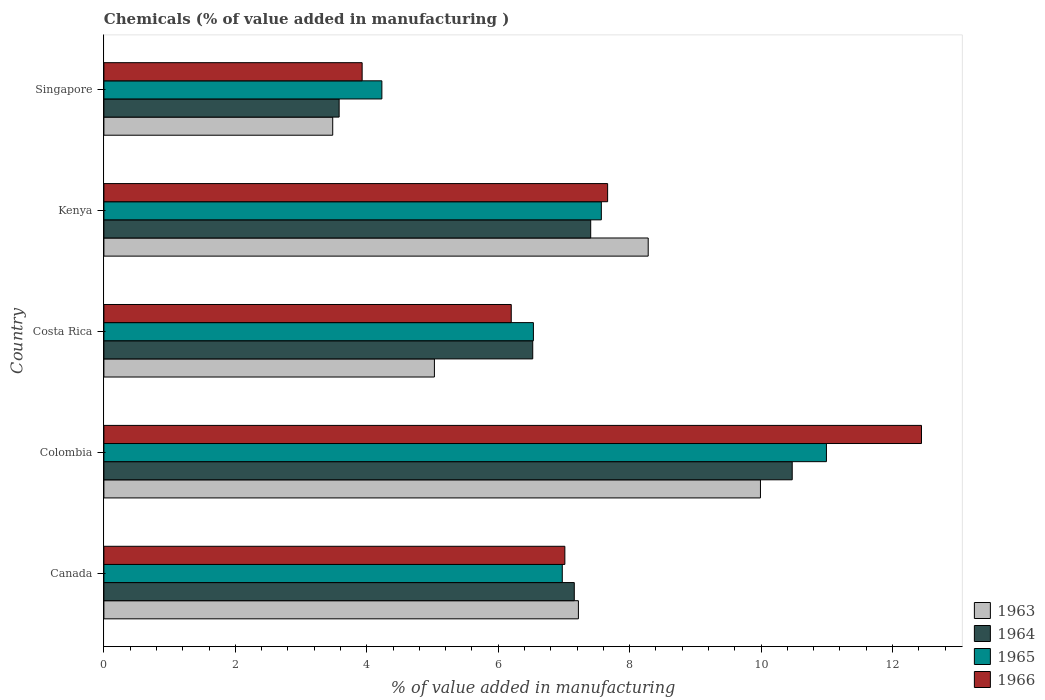How many different coloured bars are there?
Offer a very short reply. 4. Are the number of bars on each tick of the Y-axis equal?
Provide a succinct answer. Yes. How many bars are there on the 5th tick from the top?
Offer a terse response. 4. What is the label of the 2nd group of bars from the top?
Provide a short and direct response. Kenya. In how many cases, is the number of bars for a given country not equal to the number of legend labels?
Offer a terse response. 0. What is the value added in manufacturing chemicals in 1966 in Canada?
Your answer should be very brief. 7.01. Across all countries, what is the maximum value added in manufacturing chemicals in 1965?
Provide a succinct answer. 10.99. Across all countries, what is the minimum value added in manufacturing chemicals in 1965?
Keep it short and to the point. 4.23. In which country was the value added in manufacturing chemicals in 1966 minimum?
Your answer should be very brief. Singapore. What is the total value added in manufacturing chemicals in 1965 in the graph?
Your answer should be compact. 36.31. What is the difference between the value added in manufacturing chemicals in 1964 in Colombia and that in Singapore?
Offer a very short reply. 6.89. What is the difference between the value added in manufacturing chemicals in 1965 in Colombia and the value added in manufacturing chemicals in 1966 in Canada?
Provide a succinct answer. 3.98. What is the average value added in manufacturing chemicals in 1966 per country?
Offer a very short reply. 7.45. What is the difference between the value added in manufacturing chemicals in 1966 and value added in manufacturing chemicals in 1963 in Colombia?
Make the answer very short. 2.45. What is the ratio of the value added in manufacturing chemicals in 1966 in Canada to that in Singapore?
Make the answer very short. 1.78. Is the value added in manufacturing chemicals in 1964 in Canada less than that in Costa Rica?
Give a very brief answer. No. Is the difference between the value added in manufacturing chemicals in 1966 in Colombia and Singapore greater than the difference between the value added in manufacturing chemicals in 1963 in Colombia and Singapore?
Give a very brief answer. Yes. What is the difference between the highest and the second highest value added in manufacturing chemicals in 1965?
Provide a succinct answer. 3.43. What is the difference between the highest and the lowest value added in manufacturing chemicals in 1964?
Make the answer very short. 6.89. Is the sum of the value added in manufacturing chemicals in 1963 in Costa Rica and Singapore greater than the maximum value added in manufacturing chemicals in 1965 across all countries?
Ensure brevity in your answer.  No. What does the 1st bar from the top in Canada represents?
Your response must be concise. 1966. Is it the case that in every country, the sum of the value added in manufacturing chemicals in 1964 and value added in manufacturing chemicals in 1966 is greater than the value added in manufacturing chemicals in 1963?
Make the answer very short. Yes. How many bars are there?
Your answer should be very brief. 20. Are the values on the major ticks of X-axis written in scientific E-notation?
Provide a short and direct response. No. Does the graph contain grids?
Make the answer very short. No. Where does the legend appear in the graph?
Give a very brief answer. Bottom right. What is the title of the graph?
Your response must be concise. Chemicals (% of value added in manufacturing ). What is the label or title of the X-axis?
Keep it short and to the point. % of value added in manufacturing. What is the label or title of the Y-axis?
Offer a very short reply. Country. What is the % of value added in manufacturing in 1963 in Canada?
Provide a short and direct response. 7.22. What is the % of value added in manufacturing in 1964 in Canada?
Your answer should be very brief. 7.16. What is the % of value added in manufacturing of 1965 in Canada?
Give a very brief answer. 6.98. What is the % of value added in manufacturing of 1966 in Canada?
Your answer should be very brief. 7.01. What is the % of value added in manufacturing of 1963 in Colombia?
Your response must be concise. 9.99. What is the % of value added in manufacturing in 1964 in Colombia?
Your response must be concise. 10.47. What is the % of value added in manufacturing of 1965 in Colombia?
Make the answer very short. 10.99. What is the % of value added in manufacturing in 1966 in Colombia?
Offer a very short reply. 12.44. What is the % of value added in manufacturing of 1963 in Costa Rica?
Provide a succinct answer. 5.03. What is the % of value added in manufacturing in 1964 in Costa Rica?
Give a very brief answer. 6.53. What is the % of value added in manufacturing of 1965 in Costa Rica?
Provide a succinct answer. 6.54. What is the % of value added in manufacturing of 1966 in Costa Rica?
Provide a succinct answer. 6.2. What is the % of value added in manufacturing in 1963 in Kenya?
Offer a very short reply. 8.28. What is the % of value added in manufacturing in 1964 in Kenya?
Provide a short and direct response. 7.41. What is the % of value added in manufacturing of 1965 in Kenya?
Your answer should be very brief. 7.57. What is the % of value added in manufacturing in 1966 in Kenya?
Your answer should be very brief. 7.67. What is the % of value added in manufacturing in 1963 in Singapore?
Ensure brevity in your answer.  3.48. What is the % of value added in manufacturing of 1964 in Singapore?
Provide a succinct answer. 3.58. What is the % of value added in manufacturing in 1965 in Singapore?
Your answer should be compact. 4.23. What is the % of value added in manufacturing of 1966 in Singapore?
Your answer should be compact. 3.93. Across all countries, what is the maximum % of value added in manufacturing in 1963?
Your answer should be very brief. 9.99. Across all countries, what is the maximum % of value added in manufacturing of 1964?
Give a very brief answer. 10.47. Across all countries, what is the maximum % of value added in manufacturing in 1965?
Your answer should be compact. 10.99. Across all countries, what is the maximum % of value added in manufacturing in 1966?
Your answer should be very brief. 12.44. Across all countries, what is the minimum % of value added in manufacturing of 1963?
Offer a terse response. 3.48. Across all countries, what is the minimum % of value added in manufacturing of 1964?
Your response must be concise. 3.58. Across all countries, what is the minimum % of value added in manufacturing in 1965?
Give a very brief answer. 4.23. Across all countries, what is the minimum % of value added in manufacturing in 1966?
Ensure brevity in your answer.  3.93. What is the total % of value added in manufacturing of 1963 in the graph?
Your answer should be very brief. 34.01. What is the total % of value added in manufacturing in 1964 in the graph?
Provide a succinct answer. 35.15. What is the total % of value added in manufacturing in 1965 in the graph?
Offer a terse response. 36.31. What is the total % of value added in manufacturing of 1966 in the graph?
Offer a terse response. 37.25. What is the difference between the % of value added in manufacturing of 1963 in Canada and that in Colombia?
Give a very brief answer. -2.77. What is the difference between the % of value added in manufacturing of 1964 in Canada and that in Colombia?
Your answer should be very brief. -3.32. What is the difference between the % of value added in manufacturing in 1965 in Canada and that in Colombia?
Offer a very short reply. -4.02. What is the difference between the % of value added in manufacturing in 1966 in Canada and that in Colombia?
Your response must be concise. -5.43. What is the difference between the % of value added in manufacturing in 1963 in Canada and that in Costa Rica?
Your response must be concise. 2.19. What is the difference between the % of value added in manufacturing of 1964 in Canada and that in Costa Rica?
Provide a succinct answer. 0.63. What is the difference between the % of value added in manufacturing in 1965 in Canada and that in Costa Rica?
Your answer should be compact. 0.44. What is the difference between the % of value added in manufacturing of 1966 in Canada and that in Costa Rica?
Make the answer very short. 0.82. What is the difference between the % of value added in manufacturing of 1963 in Canada and that in Kenya?
Your response must be concise. -1.06. What is the difference between the % of value added in manufacturing of 1964 in Canada and that in Kenya?
Offer a terse response. -0.25. What is the difference between the % of value added in manufacturing in 1965 in Canada and that in Kenya?
Ensure brevity in your answer.  -0.59. What is the difference between the % of value added in manufacturing in 1966 in Canada and that in Kenya?
Your answer should be very brief. -0.65. What is the difference between the % of value added in manufacturing of 1963 in Canada and that in Singapore?
Provide a short and direct response. 3.74. What is the difference between the % of value added in manufacturing of 1964 in Canada and that in Singapore?
Offer a terse response. 3.58. What is the difference between the % of value added in manufacturing in 1965 in Canada and that in Singapore?
Offer a very short reply. 2.75. What is the difference between the % of value added in manufacturing of 1966 in Canada and that in Singapore?
Offer a very short reply. 3.08. What is the difference between the % of value added in manufacturing in 1963 in Colombia and that in Costa Rica?
Keep it short and to the point. 4.96. What is the difference between the % of value added in manufacturing in 1964 in Colombia and that in Costa Rica?
Your answer should be compact. 3.95. What is the difference between the % of value added in manufacturing in 1965 in Colombia and that in Costa Rica?
Keep it short and to the point. 4.46. What is the difference between the % of value added in manufacturing in 1966 in Colombia and that in Costa Rica?
Your response must be concise. 6.24. What is the difference between the % of value added in manufacturing in 1963 in Colombia and that in Kenya?
Offer a terse response. 1.71. What is the difference between the % of value added in manufacturing in 1964 in Colombia and that in Kenya?
Provide a succinct answer. 3.07. What is the difference between the % of value added in manufacturing of 1965 in Colombia and that in Kenya?
Offer a terse response. 3.43. What is the difference between the % of value added in manufacturing in 1966 in Colombia and that in Kenya?
Provide a succinct answer. 4.78. What is the difference between the % of value added in manufacturing of 1963 in Colombia and that in Singapore?
Keep it short and to the point. 6.51. What is the difference between the % of value added in manufacturing of 1964 in Colombia and that in Singapore?
Your answer should be compact. 6.89. What is the difference between the % of value added in manufacturing in 1965 in Colombia and that in Singapore?
Offer a terse response. 6.76. What is the difference between the % of value added in manufacturing in 1966 in Colombia and that in Singapore?
Ensure brevity in your answer.  8.51. What is the difference between the % of value added in manufacturing in 1963 in Costa Rica and that in Kenya?
Your response must be concise. -3.25. What is the difference between the % of value added in manufacturing of 1964 in Costa Rica and that in Kenya?
Your response must be concise. -0.88. What is the difference between the % of value added in manufacturing of 1965 in Costa Rica and that in Kenya?
Give a very brief answer. -1.03. What is the difference between the % of value added in manufacturing of 1966 in Costa Rica and that in Kenya?
Provide a succinct answer. -1.47. What is the difference between the % of value added in manufacturing in 1963 in Costa Rica and that in Singapore?
Make the answer very short. 1.55. What is the difference between the % of value added in manufacturing in 1964 in Costa Rica and that in Singapore?
Your answer should be very brief. 2.95. What is the difference between the % of value added in manufacturing of 1965 in Costa Rica and that in Singapore?
Your response must be concise. 2.31. What is the difference between the % of value added in manufacturing of 1966 in Costa Rica and that in Singapore?
Provide a short and direct response. 2.27. What is the difference between the % of value added in manufacturing in 1963 in Kenya and that in Singapore?
Your response must be concise. 4.8. What is the difference between the % of value added in manufacturing in 1964 in Kenya and that in Singapore?
Your answer should be very brief. 3.83. What is the difference between the % of value added in manufacturing in 1965 in Kenya and that in Singapore?
Keep it short and to the point. 3.34. What is the difference between the % of value added in manufacturing in 1966 in Kenya and that in Singapore?
Provide a short and direct response. 3.74. What is the difference between the % of value added in manufacturing of 1963 in Canada and the % of value added in manufacturing of 1964 in Colombia?
Provide a succinct answer. -3.25. What is the difference between the % of value added in manufacturing in 1963 in Canada and the % of value added in manufacturing in 1965 in Colombia?
Your answer should be compact. -3.77. What is the difference between the % of value added in manufacturing of 1963 in Canada and the % of value added in manufacturing of 1966 in Colombia?
Make the answer very short. -5.22. What is the difference between the % of value added in manufacturing of 1964 in Canada and the % of value added in manufacturing of 1965 in Colombia?
Give a very brief answer. -3.84. What is the difference between the % of value added in manufacturing of 1964 in Canada and the % of value added in manufacturing of 1966 in Colombia?
Offer a very short reply. -5.28. What is the difference between the % of value added in manufacturing of 1965 in Canada and the % of value added in manufacturing of 1966 in Colombia?
Ensure brevity in your answer.  -5.47. What is the difference between the % of value added in manufacturing of 1963 in Canada and the % of value added in manufacturing of 1964 in Costa Rica?
Offer a terse response. 0.69. What is the difference between the % of value added in manufacturing in 1963 in Canada and the % of value added in manufacturing in 1965 in Costa Rica?
Make the answer very short. 0.68. What is the difference between the % of value added in manufacturing in 1963 in Canada and the % of value added in manufacturing in 1966 in Costa Rica?
Make the answer very short. 1.02. What is the difference between the % of value added in manufacturing of 1964 in Canada and the % of value added in manufacturing of 1965 in Costa Rica?
Provide a short and direct response. 0.62. What is the difference between the % of value added in manufacturing in 1964 in Canada and the % of value added in manufacturing in 1966 in Costa Rica?
Make the answer very short. 0.96. What is the difference between the % of value added in manufacturing of 1965 in Canada and the % of value added in manufacturing of 1966 in Costa Rica?
Provide a short and direct response. 0.78. What is the difference between the % of value added in manufacturing of 1963 in Canada and the % of value added in manufacturing of 1964 in Kenya?
Provide a succinct answer. -0.19. What is the difference between the % of value added in manufacturing in 1963 in Canada and the % of value added in manufacturing in 1965 in Kenya?
Keep it short and to the point. -0.35. What is the difference between the % of value added in manufacturing of 1963 in Canada and the % of value added in manufacturing of 1966 in Kenya?
Provide a succinct answer. -0.44. What is the difference between the % of value added in manufacturing of 1964 in Canada and the % of value added in manufacturing of 1965 in Kenya?
Offer a very short reply. -0.41. What is the difference between the % of value added in manufacturing in 1964 in Canada and the % of value added in manufacturing in 1966 in Kenya?
Keep it short and to the point. -0.51. What is the difference between the % of value added in manufacturing of 1965 in Canada and the % of value added in manufacturing of 1966 in Kenya?
Give a very brief answer. -0.69. What is the difference between the % of value added in manufacturing in 1963 in Canada and the % of value added in manufacturing in 1964 in Singapore?
Your answer should be compact. 3.64. What is the difference between the % of value added in manufacturing in 1963 in Canada and the % of value added in manufacturing in 1965 in Singapore?
Provide a succinct answer. 2.99. What is the difference between the % of value added in manufacturing in 1963 in Canada and the % of value added in manufacturing in 1966 in Singapore?
Ensure brevity in your answer.  3.29. What is the difference between the % of value added in manufacturing in 1964 in Canada and the % of value added in manufacturing in 1965 in Singapore?
Offer a terse response. 2.93. What is the difference between the % of value added in manufacturing in 1964 in Canada and the % of value added in manufacturing in 1966 in Singapore?
Provide a succinct answer. 3.23. What is the difference between the % of value added in manufacturing in 1965 in Canada and the % of value added in manufacturing in 1966 in Singapore?
Ensure brevity in your answer.  3.05. What is the difference between the % of value added in manufacturing in 1963 in Colombia and the % of value added in manufacturing in 1964 in Costa Rica?
Your response must be concise. 3.47. What is the difference between the % of value added in manufacturing in 1963 in Colombia and the % of value added in manufacturing in 1965 in Costa Rica?
Make the answer very short. 3.46. What is the difference between the % of value added in manufacturing of 1963 in Colombia and the % of value added in manufacturing of 1966 in Costa Rica?
Ensure brevity in your answer.  3.79. What is the difference between the % of value added in manufacturing in 1964 in Colombia and the % of value added in manufacturing in 1965 in Costa Rica?
Your answer should be compact. 3.94. What is the difference between the % of value added in manufacturing in 1964 in Colombia and the % of value added in manufacturing in 1966 in Costa Rica?
Offer a very short reply. 4.28. What is the difference between the % of value added in manufacturing in 1965 in Colombia and the % of value added in manufacturing in 1966 in Costa Rica?
Offer a terse response. 4.8. What is the difference between the % of value added in manufacturing in 1963 in Colombia and the % of value added in manufacturing in 1964 in Kenya?
Your response must be concise. 2.58. What is the difference between the % of value added in manufacturing in 1963 in Colombia and the % of value added in manufacturing in 1965 in Kenya?
Offer a terse response. 2.42. What is the difference between the % of value added in manufacturing in 1963 in Colombia and the % of value added in manufacturing in 1966 in Kenya?
Your answer should be compact. 2.33. What is the difference between the % of value added in manufacturing in 1964 in Colombia and the % of value added in manufacturing in 1965 in Kenya?
Your answer should be very brief. 2.9. What is the difference between the % of value added in manufacturing in 1964 in Colombia and the % of value added in manufacturing in 1966 in Kenya?
Your answer should be compact. 2.81. What is the difference between the % of value added in manufacturing in 1965 in Colombia and the % of value added in manufacturing in 1966 in Kenya?
Ensure brevity in your answer.  3.33. What is the difference between the % of value added in manufacturing in 1963 in Colombia and the % of value added in manufacturing in 1964 in Singapore?
Offer a very short reply. 6.41. What is the difference between the % of value added in manufacturing of 1963 in Colombia and the % of value added in manufacturing of 1965 in Singapore?
Make the answer very short. 5.76. What is the difference between the % of value added in manufacturing of 1963 in Colombia and the % of value added in manufacturing of 1966 in Singapore?
Ensure brevity in your answer.  6.06. What is the difference between the % of value added in manufacturing of 1964 in Colombia and the % of value added in manufacturing of 1965 in Singapore?
Make the answer very short. 6.24. What is the difference between the % of value added in manufacturing in 1964 in Colombia and the % of value added in manufacturing in 1966 in Singapore?
Ensure brevity in your answer.  6.54. What is the difference between the % of value added in manufacturing in 1965 in Colombia and the % of value added in manufacturing in 1966 in Singapore?
Make the answer very short. 7.07. What is the difference between the % of value added in manufacturing of 1963 in Costa Rica and the % of value added in manufacturing of 1964 in Kenya?
Make the answer very short. -2.38. What is the difference between the % of value added in manufacturing in 1963 in Costa Rica and the % of value added in manufacturing in 1965 in Kenya?
Offer a very short reply. -2.54. What is the difference between the % of value added in manufacturing of 1963 in Costa Rica and the % of value added in manufacturing of 1966 in Kenya?
Give a very brief answer. -2.64. What is the difference between the % of value added in manufacturing in 1964 in Costa Rica and the % of value added in manufacturing in 1965 in Kenya?
Your answer should be compact. -1.04. What is the difference between the % of value added in manufacturing of 1964 in Costa Rica and the % of value added in manufacturing of 1966 in Kenya?
Ensure brevity in your answer.  -1.14. What is the difference between the % of value added in manufacturing in 1965 in Costa Rica and the % of value added in manufacturing in 1966 in Kenya?
Your response must be concise. -1.13. What is the difference between the % of value added in manufacturing of 1963 in Costa Rica and the % of value added in manufacturing of 1964 in Singapore?
Offer a terse response. 1.45. What is the difference between the % of value added in manufacturing of 1963 in Costa Rica and the % of value added in manufacturing of 1965 in Singapore?
Your answer should be very brief. 0.8. What is the difference between the % of value added in manufacturing of 1963 in Costa Rica and the % of value added in manufacturing of 1966 in Singapore?
Your response must be concise. 1.1. What is the difference between the % of value added in manufacturing in 1964 in Costa Rica and the % of value added in manufacturing in 1965 in Singapore?
Your answer should be very brief. 2.3. What is the difference between the % of value added in manufacturing in 1964 in Costa Rica and the % of value added in manufacturing in 1966 in Singapore?
Keep it short and to the point. 2.6. What is the difference between the % of value added in manufacturing of 1965 in Costa Rica and the % of value added in manufacturing of 1966 in Singapore?
Offer a terse response. 2.61. What is the difference between the % of value added in manufacturing in 1963 in Kenya and the % of value added in manufacturing in 1964 in Singapore?
Offer a very short reply. 4.7. What is the difference between the % of value added in manufacturing in 1963 in Kenya and the % of value added in manufacturing in 1965 in Singapore?
Offer a terse response. 4.05. What is the difference between the % of value added in manufacturing in 1963 in Kenya and the % of value added in manufacturing in 1966 in Singapore?
Your response must be concise. 4.35. What is the difference between the % of value added in manufacturing of 1964 in Kenya and the % of value added in manufacturing of 1965 in Singapore?
Your response must be concise. 3.18. What is the difference between the % of value added in manufacturing of 1964 in Kenya and the % of value added in manufacturing of 1966 in Singapore?
Make the answer very short. 3.48. What is the difference between the % of value added in manufacturing in 1965 in Kenya and the % of value added in manufacturing in 1966 in Singapore?
Keep it short and to the point. 3.64. What is the average % of value added in manufacturing of 1963 per country?
Offer a very short reply. 6.8. What is the average % of value added in manufacturing of 1964 per country?
Make the answer very short. 7.03. What is the average % of value added in manufacturing in 1965 per country?
Your response must be concise. 7.26. What is the average % of value added in manufacturing of 1966 per country?
Your answer should be very brief. 7.45. What is the difference between the % of value added in manufacturing of 1963 and % of value added in manufacturing of 1964 in Canada?
Provide a succinct answer. 0.06. What is the difference between the % of value added in manufacturing in 1963 and % of value added in manufacturing in 1965 in Canada?
Offer a very short reply. 0.25. What is the difference between the % of value added in manufacturing in 1963 and % of value added in manufacturing in 1966 in Canada?
Your response must be concise. 0.21. What is the difference between the % of value added in manufacturing of 1964 and % of value added in manufacturing of 1965 in Canada?
Keep it short and to the point. 0.18. What is the difference between the % of value added in manufacturing in 1964 and % of value added in manufacturing in 1966 in Canada?
Your answer should be very brief. 0.14. What is the difference between the % of value added in manufacturing of 1965 and % of value added in manufacturing of 1966 in Canada?
Offer a terse response. -0.04. What is the difference between the % of value added in manufacturing of 1963 and % of value added in manufacturing of 1964 in Colombia?
Give a very brief answer. -0.48. What is the difference between the % of value added in manufacturing of 1963 and % of value added in manufacturing of 1965 in Colombia?
Provide a succinct answer. -1. What is the difference between the % of value added in manufacturing of 1963 and % of value added in manufacturing of 1966 in Colombia?
Your answer should be very brief. -2.45. What is the difference between the % of value added in manufacturing in 1964 and % of value added in manufacturing in 1965 in Colombia?
Ensure brevity in your answer.  -0.52. What is the difference between the % of value added in manufacturing in 1964 and % of value added in manufacturing in 1966 in Colombia?
Your answer should be very brief. -1.97. What is the difference between the % of value added in manufacturing in 1965 and % of value added in manufacturing in 1966 in Colombia?
Give a very brief answer. -1.45. What is the difference between the % of value added in manufacturing in 1963 and % of value added in manufacturing in 1964 in Costa Rica?
Give a very brief answer. -1.5. What is the difference between the % of value added in manufacturing of 1963 and % of value added in manufacturing of 1965 in Costa Rica?
Ensure brevity in your answer.  -1.51. What is the difference between the % of value added in manufacturing of 1963 and % of value added in manufacturing of 1966 in Costa Rica?
Offer a terse response. -1.17. What is the difference between the % of value added in manufacturing in 1964 and % of value added in manufacturing in 1965 in Costa Rica?
Your answer should be very brief. -0.01. What is the difference between the % of value added in manufacturing of 1964 and % of value added in manufacturing of 1966 in Costa Rica?
Provide a short and direct response. 0.33. What is the difference between the % of value added in manufacturing in 1965 and % of value added in manufacturing in 1966 in Costa Rica?
Keep it short and to the point. 0.34. What is the difference between the % of value added in manufacturing of 1963 and % of value added in manufacturing of 1964 in Kenya?
Your answer should be very brief. 0.87. What is the difference between the % of value added in manufacturing in 1963 and % of value added in manufacturing in 1965 in Kenya?
Provide a short and direct response. 0.71. What is the difference between the % of value added in manufacturing of 1963 and % of value added in manufacturing of 1966 in Kenya?
Offer a terse response. 0.62. What is the difference between the % of value added in manufacturing in 1964 and % of value added in manufacturing in 1965 in Kenya?
Your response must be concise. -0.16. What is the difference between the % of value added in manufacturing in 1964 and % of value added in manufacturing in 1966 in Kenya?
Provide a succinct answer. -0.26. What is the difference between the % of value added in manufacturing in 1965 and % of value added in manufacturing in 1966 in Kenya?
Give a very brief answer. -0.1. What is the difference between the % of value added in manufacturing of 1963 and % of value added in manufacturing of 1964 in Singapore?
Provide a short and direct response. -0.1. What is the difference between the % of value added in manufacturing of 1963 and % of value added in manufacturing of 1965 in Singapore?
Provide a short and direct response. -0.75. What is the difference between the % of value added in manufacturing in 1963 and % of value added in manufacturing in 1966 in Singapore?
Provide a short and direct response. -0.45. What is the difference between the % of value added in manufacturing in 1964 and % of value added in manufacturing in 1965 in Singapore?
Your response must be concise. -0.65. What is the difference between the % of value added in manufacturing in 1964 and % of value added in manufacturing in 1966 in Singapore?
Offer a very short reply. -0.35. What is the difference between the % of value added in manufacturing in 1965 and % of value added in manufacturing in 1966 in Singapore?
Your answer should be very brief. 0.3. What is the ratio of the % of value added in manufacturing in 1963 in Canada to that in Colombia?
Offer a very short reply. 0.72. What is the ratio of the % of value added in manufacturing of 1964 in Canada to that in Colombia?
Provide a succinct answer. 0.68. What is the ratio of the % of value added in manufacturing in 1965 in Canada to that in Colombia?
Your answer should be compact. 0.63. What is the ratio of the % of value added in manufacturing in 1966 in Canada to that in Colombia?
Your response must be concise. 0.56. What is the ratio of the % of value added in manufacturing of 1963 in Canada to that in Costa Rica?
Provide a succinct answer. 1.44. What is the ratio of the % of value added in manufacturing in 1964 in Canada to that in Costa Rica?
Your response must be concise. 1.1. What is the ratio of the % of value added in manufacturing in 1965 in Canada to that in Costa Rica?
Your response must be concise. 1.07. What is the ratio of the % of value added in manufacturing in 1966 in Canada to that in Costa Rica?
Offer a very short reply. 1.13. What is the ratio of the % of value added in manufacturing of 1963 in Canada to that in Kenya?
Ensure brevity in your answer.  0.87. What is the ratio of the % of value added in manufacturing in 1964 in Canada to that in Kenya?
Provide a succinct answer. 0.97. What is the ratio of the % of value added in manufacturing in 1965 in Canada to that in Kenya?
Your response must be concise. 0.92. What is the ratio of the % of value added in manufacturing of 1966 in Canada to that in Kenya?
Make the answer very short. 0.92. What is the ratio of the % of value added in manufacturing in 1963 in Canada to that in Singapore?
Ensure brevity in your answer.  2.07. What is the ratio of the % of value added in manufacturing in 1964 in Canada to that in Singapore?
Your answer should be compact. 2. What is the ratio of the % of value added in manufacturing in 1965 in Canada to that in Singapore?
Give a very brief answer. 1.65. What is the ratio of the % of value added in manufacturing in 1966 in Canada to that in Singapore?
Make the answer very short. 1.78. What is the ratio of the % of value added in manufacturing of 1963 in Colombia to that in Costa Rica?
Make the answer very short. 1.99. What is the ratio of the % of value added in manufacturing in 1964 in Colombia to that in Costa Rica?
Offer a terse response. 1.61. What is the ratio of the % of value added in manufacturing in 1965 in Colombia to that in Costa Rica?
Keep it short and to the point. 1.68. What is the ratio of the % of value added in manufacturing of 1966 in Colombia to that in Costa Rica?
Offer a terse response. 2.01. What is the ratio of the % of value added in manufacturing in 1963 in Colombia to that in Kenya?
Provide a short and direct response. 1.21. What is the ratio of the % of value added in manufacturing of 1964 in Colombia to that in Kenya?
Your response must be concise. 1.41. What is the ratio of the % of value added in manufacturing in 1965 in Colombia to that in Kenya?
Ensure brevity in your answer.  1.45. What is the ratio of the % of value added in manufacturing of 1966 in Colombia to that in Kenya?
Give a very brief answer. 1.62. What is the ratio of the % of value added in manufacturing of 1963 in Colombia to that in Singapore?
Offer a terse response. 2.87. What is the ratio of the % of value added in manufacturing in 1964 in Colombia to that in Singapore?
Give a very brief answer. 2.93. What is the ratio of the % of value added in manufacturing of 1965 in Colombia to that in Singapore?
Your response must be concise. 2.6. What is the ratio of the % of value added in manufacturing in 1966 in Colombia to that in Singapore?
Your response must be concise. 3.17. What is the ratio of the % of value added in manufacturing in 1963 in Costa Rica to that in Kenya?
Give a very brief answer. 0.61. What is the ratio of the % of value added in manufacturing in 1964 in Costa Rica to that in Kenya?
Your answer should be very brief. 0.88. What is the ratio of the % of value added in manufacturing of 1965 in Costa Rica to that in Kenya?
Keep it short and to the point. 0.86. What is the ratio of the % of value added in manufacturing of 1966 in Costa Rica to that in Kenya?
Your answer should be compact. 0.81. What is the ratio of the % of value added in manufacturing of 1963 in Costa Rica to that in Singapore?
Offer a very short reply. 1.44. What is the ratio of the % of value added in manufacturing in 1964 in Costa Rica to that in Singapore?
Offer a terse response. 1.82. What is the ratio of the % of value added in manufacturing in 1965 in Costa Rica to that in Singapore?
Make the answer very short. 1.55. What is the ratio of the % of value added in manufacturing of 1966 in Costa Rica to that in Singapore?
Ensure brevity in your answer.  1.58. What is the ratio of the % of value added in manufacturing in 1963 in Kenya to that in Singapore?
Your response must be concise. 2.38. What is the ratio of the % of value added in manufacturing of 1964 in Kenya to that in Singapore?
Offer a terse response. 2.07. What is the ratio of the % of value added in manufacturing in 1965 in Kenya to that in Singapore?
Your answer should be very brief. 1.79. What is the ratio of the % of value added in manufacturing of 1966 in Kenya to that in Singapore?
Ensure brevity in your answer.  1.95. What is the difference between the highest and the second highest % of value added in manufacturing in 1963?
Your response must be concise. 1.71. What is the difference between the highest and the second highest % of value added in manufacturing of 1964?
Offer a terse response. 3.07. What is the difference between the highest and the second highest % of value added in manufacturing in 1965?
Offer a terse response. 3.43. What is the difference between the highest and the second highest % of value added in manufacturing in 1966?
Your answer should be very brief. 4.78. What is the difference between the highest and the lowest % of value added in manufacturing in 1963?
Offer a terse response. 6.51. What is the difference between the highest and the lowest % of value added in manufacturing of 1964?
Keep it short and to the point. 6.89. What is the difference between the highest and the lowest % of value added in manufacturing of 1965?
Provide a succinct answer. 6.76. What is the difference between the highest and the lowest % of value added in manufacturing in 1966?
Give a very brief answer. 8.51. 